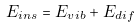<formula> <loc_0><loc_0><loc_500><loc_500>E _ { i n s } = E _ { v i b } + E _ { d i f }</formula> 